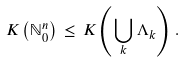<formula> <loc_0><loc_0><loc_500><loc_500>K \left ( \mathbb { N } _ { 0 } ^ { n } \right ) \, \leq \, K \left ( \bigcup _ { k } \Lambda _ { k } \right ) \, .</formula> 